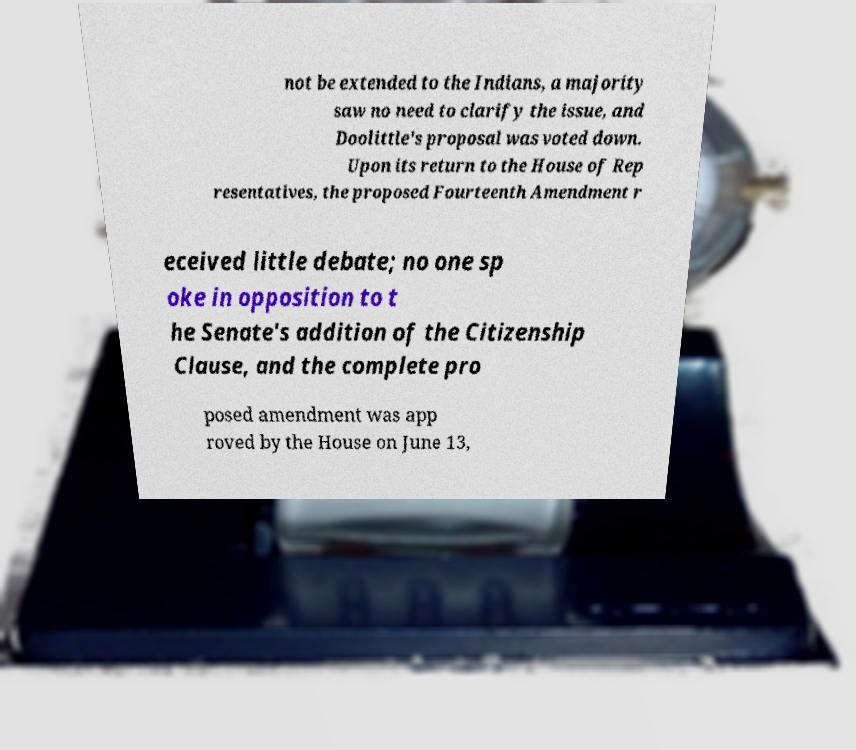Can you read and provide the text displayed in the image?This photo seems to have some interesting text. Can you extract and type it out for me? not be extended to the Indians, a majority saw no need to clarify the issue, and Doolittle's proposal was voted down. Upon its return to the House of Rep resentatives, the proposed Fourteenth Amendment r eceived little debate; no one sp oke in opposition to t he Senate's addition of the Citizenship Clause, and the complete pro posed amendment was app roved by the House on June 13, 